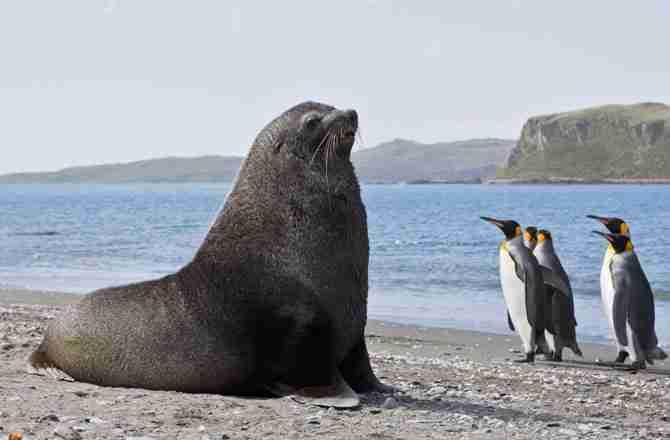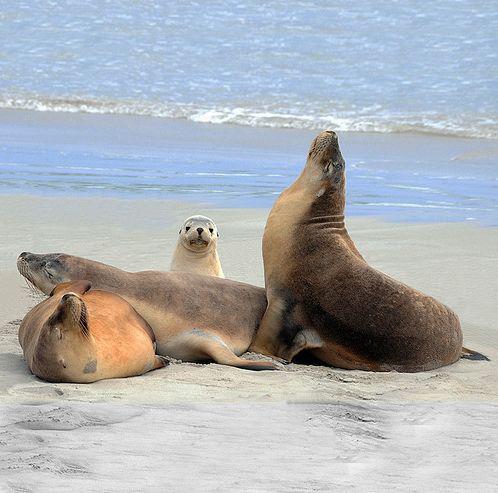The first image is the image on the left, the second image is the image on the right. Assess this claim about the two images: "The left image contains no more than one seal.". Correct or not? Answer yes or no. Yes. The first image is the image on the left, the second image is the image on the right. Analyze the images presented: Is the assertion "A single seal is on the beach in the image on the left." valid? Answer yes or no. Yes. 